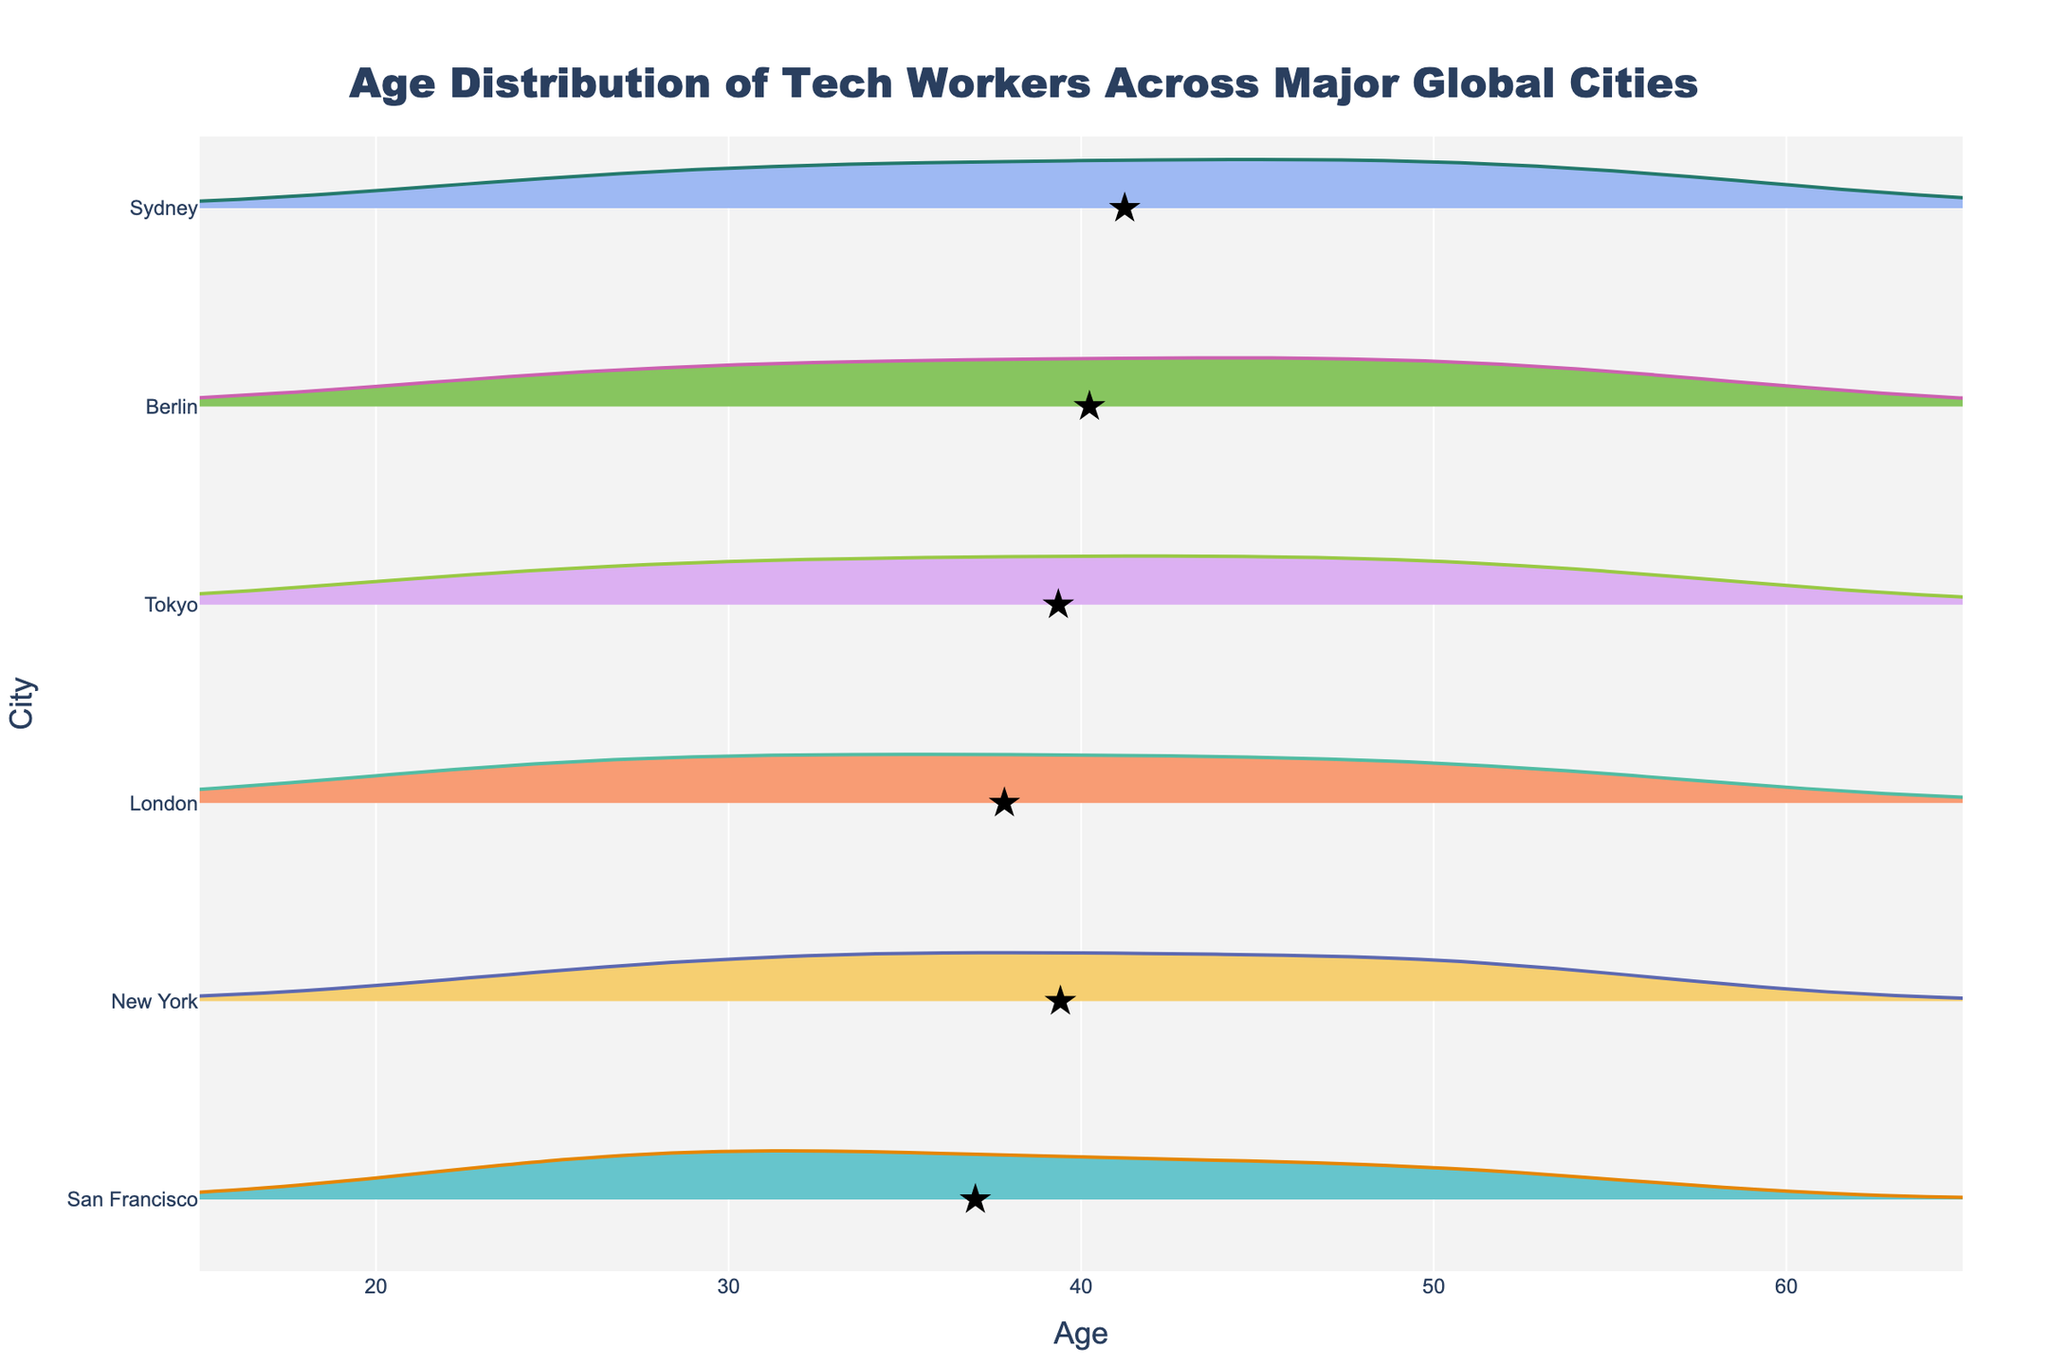What is the title of the figure? The title is usually located at the top of the figure and it gives an overview of what the figure represents. Here, it states "Age Distribution of Tech Workers Across Major Global Cities".
Answer: Age Distribution of Tech Workers Across Major Global Cities Which city has the widest age range of tech workers? To determine the city with the widest age range, we look at the span of the violin plots. The city where the plot extends from the lowest to highest ages is the one with the widest range.
Answer: Sydney What is the age range of tech workers in New York? Check the horizontal span of the violin plot for New York. It starts around 23 and ends around 55. Subtract the minimum age from the maximum age.
Answer: 23 to 55 Which city has the youngest tech workers on average? Look for the star markers indicating the average/mean age in each city's violin plot. The city with the star closest to the left (younger age) has the youngest average.
Answer: San Francisco How does the average age of tech workers in Berlin compare to that in Tokyo? First, identify the locations of the star markers for Berlin and Tokyo. Compare their positions on the horizontal axis to determine which one is higher or lower.
Answer: Berlin has an older average age What is the highest age depicted in the violin plot for London? Check the rightmost edge of the violin plot for London. This indicates the maximum age data point for that city.
Answer: 56 Across all cities, which has the smallest range of tech worker ages? Identify the city with the narrowest violin plot span from left to right. This represents the smallest age range.
Answer: San Francisco How evenly distributed are tech worker ages in Sydney compared to New York? Assess the shape and spread of the violin plots. A wider and more symmetrical shape indicates more even distribution. Compare the symmetry and spread for Sydney and New York.
Answer: Sydney is more evenly distributed Which city has the oldest tech worker? Identify the violin plot with the rightmost data point. This represents the oldest age among all the cities.
Answer: Sydney What is the median age range of tech workers in Berlin? Determine the horizontal span of the middle 50% of the Berlin violin plot, where the density is thickest. This represents the interquartile range (IQR) containing the median ages.
Answer: 32 to 51 